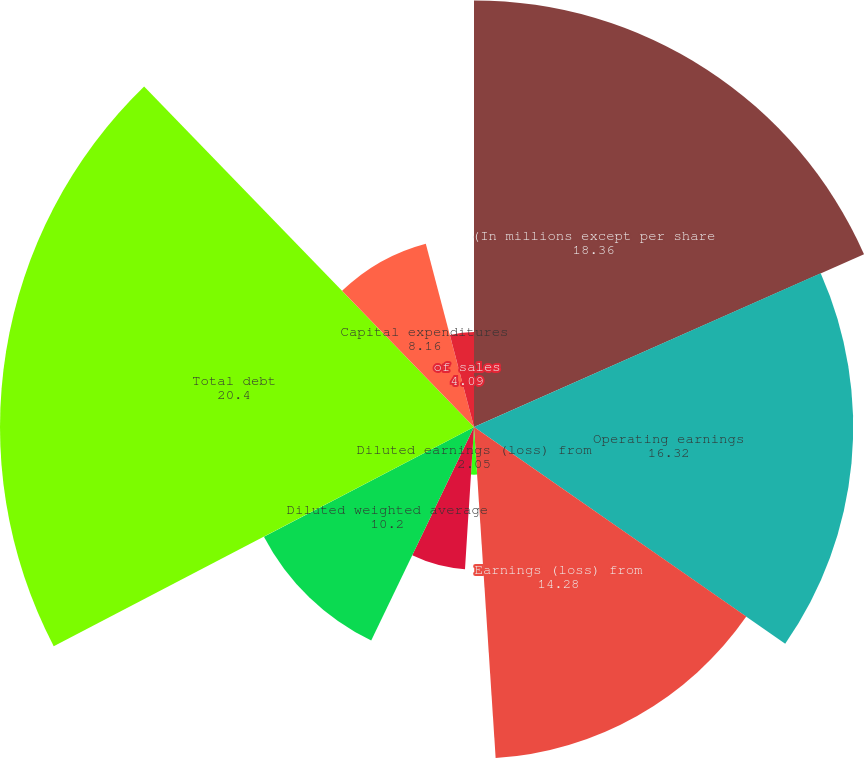Convert chart to OTSL. <chart><loc_0><loc_0><loc_500><loc_500><pie_chart><fcel>(In millions except per share<fcel>Operating earnings<fcel>Earnings (loss) from<fcel>Diluted earnings (loss) from<fcel>Earnings (loss) per diluted<fcel>Diluted weighted average<fcel>Dividends declared per share<fcel>Total debt<fcel>Capital expenditures<fcel>of sales<nl><fcel>18.36%<fcel>16.32%<fcel>14.28%<fcel>2.05%<fcel>6.13%<fcel>10.2%<fcel>0.01%<fcel>20.4%<fcel>8.16%<fcel>4.09%<nl></chart> 